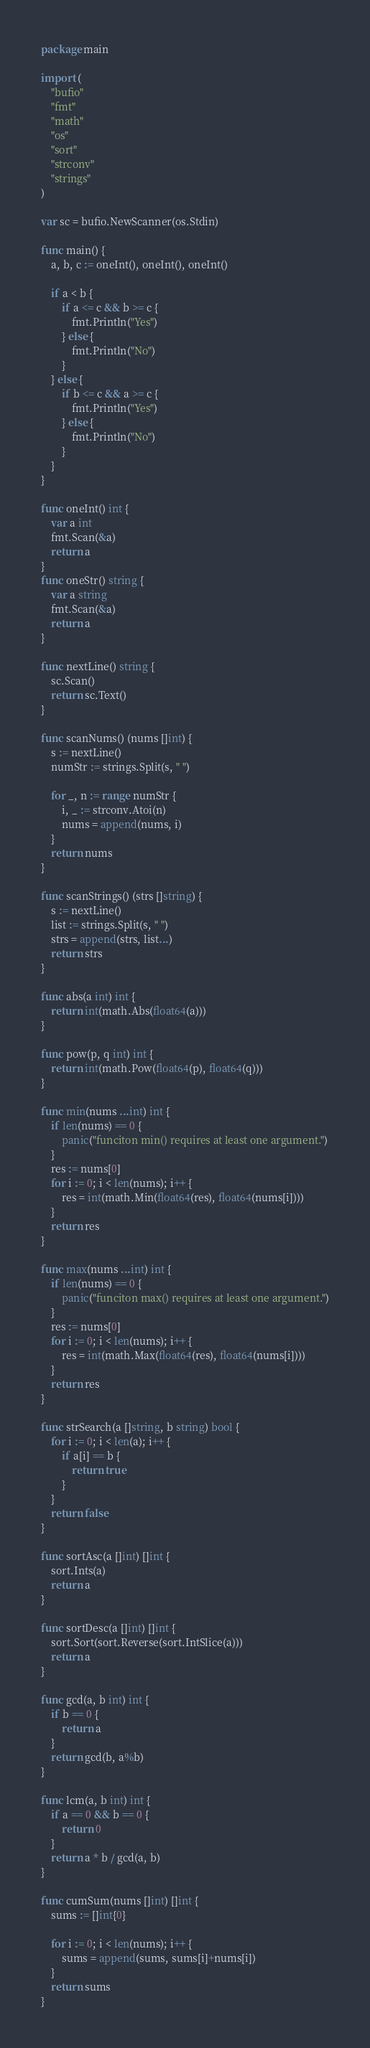<code> <loc_0><loc_0><loc_500><loc_500><_Go_>package main

import (
	"bufio"
	"fmt"
	"math"
	"os"
	"sort"
	"strconv"
	"strings"
)

var sc = bufio.NewScanner(os.Stdin)

func main() {
	a, b, c := oneInt(), oneInt(), oneInt()

	if a < b {
		if a <= c && b >= c {
			fmt.Println("Yes")
		} else {
			fmt.Println("No")
		}
	} else {
		if b <= c && a >= c {
			fmt.Println("Yes")
		} else {
			fmt.Println("No")
		}
	}
}

func oneInt() int {
	var a int
	fmt.Scan(&a)
	return a
}
func oneStr() string {
	var a string
	fmt.Scan(&a)
	return a
}

func nextLine() string {
	sc.Scan()
	return sc.Text()
}

func scanNums() (nums []int) {
	s := nextLine()
	numStr := strings.Split(s, " ")

	for _, n := range numStr {
		i, _ := strconv.Atoi(n)
		nums = append(nums, i)
	}
	return nums
}

func scanStrings() (strs []string) {
	s := nextLine()
	list := strings.Split(s, " ")
	strs = append(strs, list...)
	return strs
}

func abs(a int) int {
	return int(math.Abs(float64(a)))
}

func pow(p, q int) int {
	return int(math.Pow(float64(p), float64(q)))
}

func min(nums ...int) int {
	if len(nums) == 0 {
		panic("funciton min() requires at least one argument.")
	}
	res := nums[0]
	for i := 0; i < len(nums); i++ {
		res = int(math.Min(float64(res), float64(nums[i])))
	}
	return res
}

func max(nums ...int) int {
	if len(nums) == 0 {
		panic("funciton max() requires at least one argument.")
	}
	res := nums[0]
	for i := 0; i < len(nums); i++ {
		res = int(math.Max(float64(res), float64(nums[i])))
	}
	return res
}

func strSearch(a []string, b string) bool {
	for i := 0; i < len(a); i++ {
		if a[i] == b {
			return true
		}
	}
	return false
}

func sortAsc(a []int) []int {
	sort.Ints(a)
	return a
}

func sortDesc(a []int) []int {
	sort.Sort(sort.Reverse(sort.IntSlice(a)))
	return a
}

func gcd(a, b int) int {
	if b == 0 {
		return a
	}
	return gcd(b, a%b)
}

func lcm(a, b int) int {
	if a == 0 && b == 0 {
		return 0
	}
	return a * b / gcd(a, b)
}

func cumSum(nums []int) []int {
	sums := []int{0}

	for i := 0; i < len(nums); i++ {
		sums = append(sums, sums[i]+nums[i])
	}
	return sums
}
</code> 